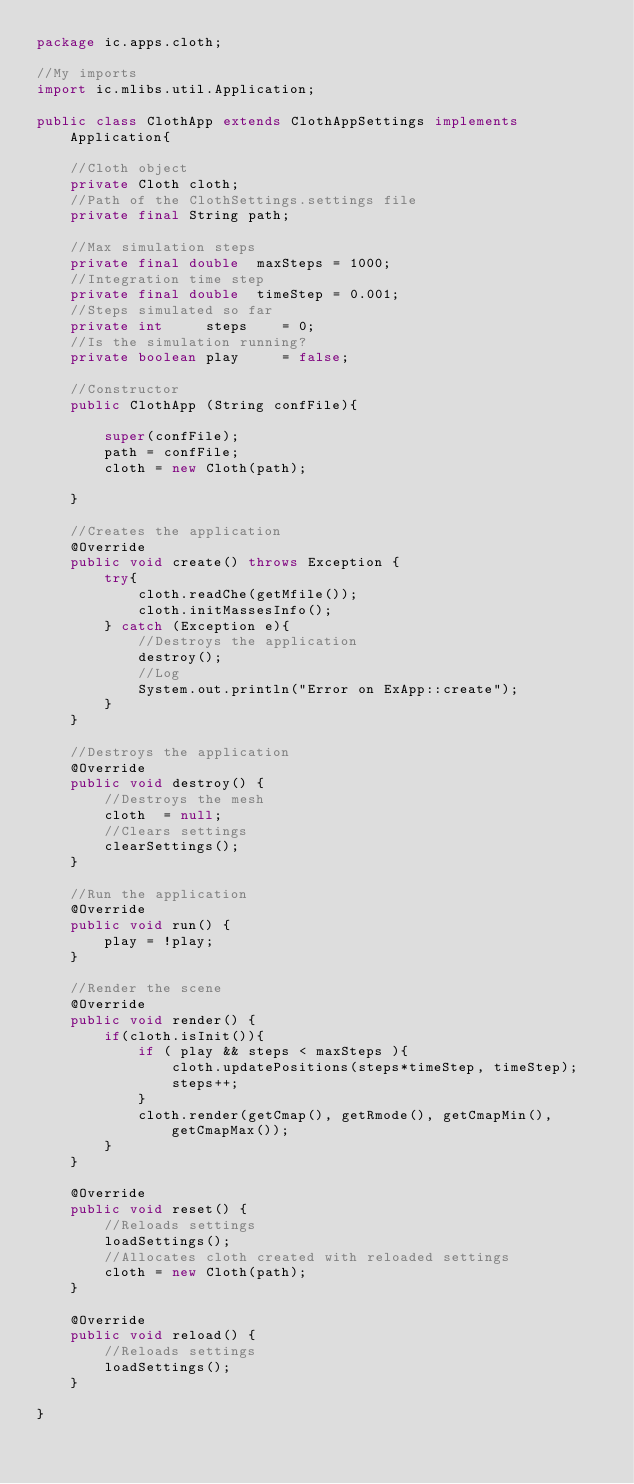Convert code to text. <code><loc_0><loc_0><loc_500><loc_500><_Java_>package ic.apps.cloth;

//My imports
import ic.mlibs.util.Application;

public class ClothApp extends ClothAppSettings implements Application{
    
    //Cloth object
    private Cloth cloth;
    //Path of the ClothSettings.settings file
    private final String path;
    
    //Max simulation steps
    private final double  maxSteps = 1000;
    //Integration time step
    private final double  timeStep = 0.001;
    //Steps simulated so far
    private int     steps    = 0;
    //Is the simulation running?
    private boolean play     = false;
   
    //Constructor
    public ClothApp (String confFile){
        
        super(confFile);
        path = confFile;
        cloth = new Cloth(path);
    
    }
    
    //Creates the application
    @Override
    public void create() throws Exception {
        try{
            cloth.readChe(getMfile());
            cloth.initMassesInfo();
        } catch (Exception e){
            //Destroys the application
            destroy();
            //Log
            System.out.println("Error on ExApp::create");
        }
    }

    //Destroys the application
    @Override
    public void destroy() {
        //Destroys the mesh
        cloth  = null;
        //Clears settings
        clearSettings();
    }

    //Run the application
    @Override
    public void run() {
        play = !play;
    }

    //Render the scene
    @Override
    public void render() {
        if(cloth.isInit()){
            if ( play && steps < maxSteps ){
                cloth.updatePositions(steps*timeStep, timeStep);
                steps++;
            }
            cloth.render(getCmap(), getRmode(), getCmapMin(), getCmapMax());            
        }
    }

    @Override
    public void reset() {
        //Reloads settings
        loadSettings();
        //Allocates cloth created with reloaded settings
        cloth = new Cloth(path);
    }

    @Override
    public void reload() {
        //Reloads settings
        loadSettings();
    }
    
}
</code> 